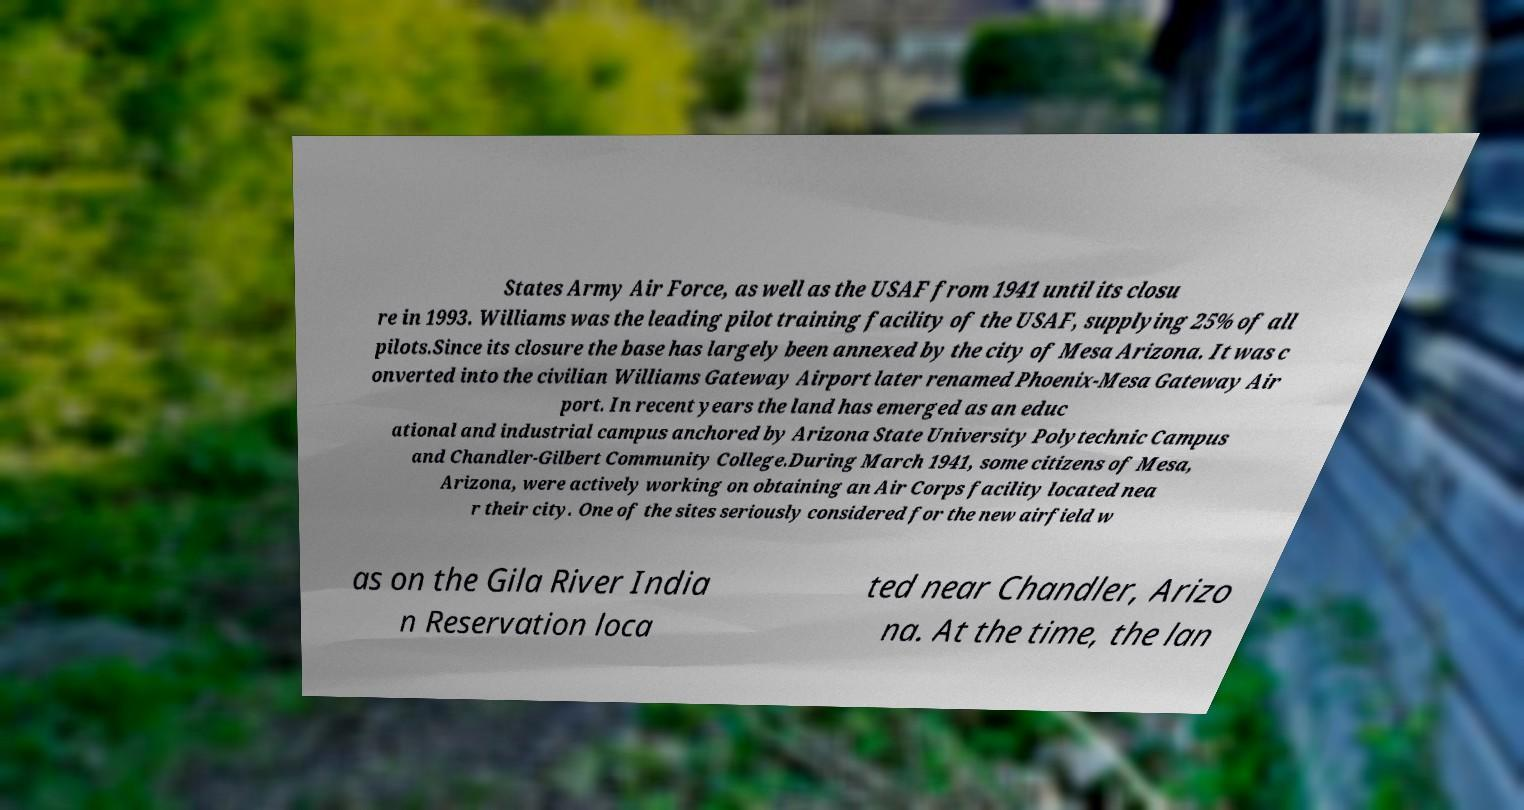I need the written content from this picture converted into text. Can you do that? States Army Air Force, as well as the USAF from 1941 until its closu re in 1993. Williams was the leading pilot training facility of the USAF, supplying 25% of all pilots.Since its closure the base has largely been annexed by the city of Mesa Arizona. It was c onverted into the civilian Williams Gateway Airport later renamed Phoenix-Mesa Gateway Air port. In recent years the land has emerged as an educ ational and industrial campus anchored by Arizona State University Polytechnic Campus and Chandler-Gilbert Community College.During March 1941, some citizens of Mesa, Arizona, were actively working on obtaining an Air Corps facility located nea r their city. One of the sites seriously considered for the new airfield w as on the Gila River India n Reservation loca ted near Chandler, Arizo na. At the time, the lan 